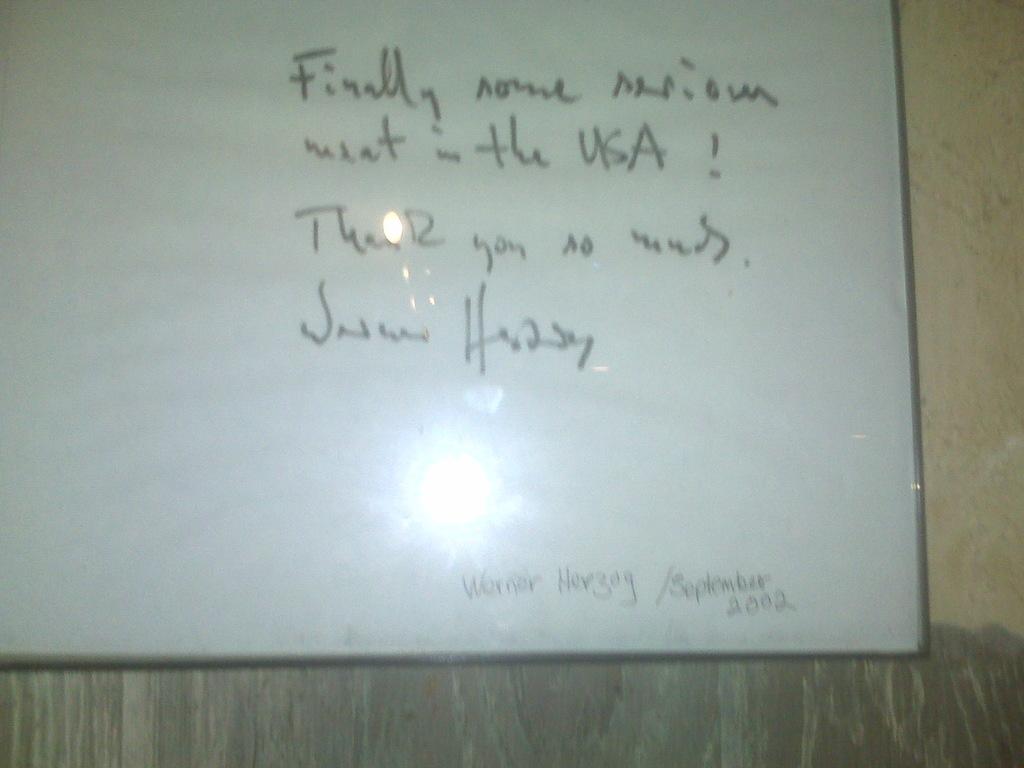What month and year is mentioned at the bottom?
Your response must be concise. September 2002. Who wrote the message in the picture?
Your answer should be very brief. Unanswerable. 